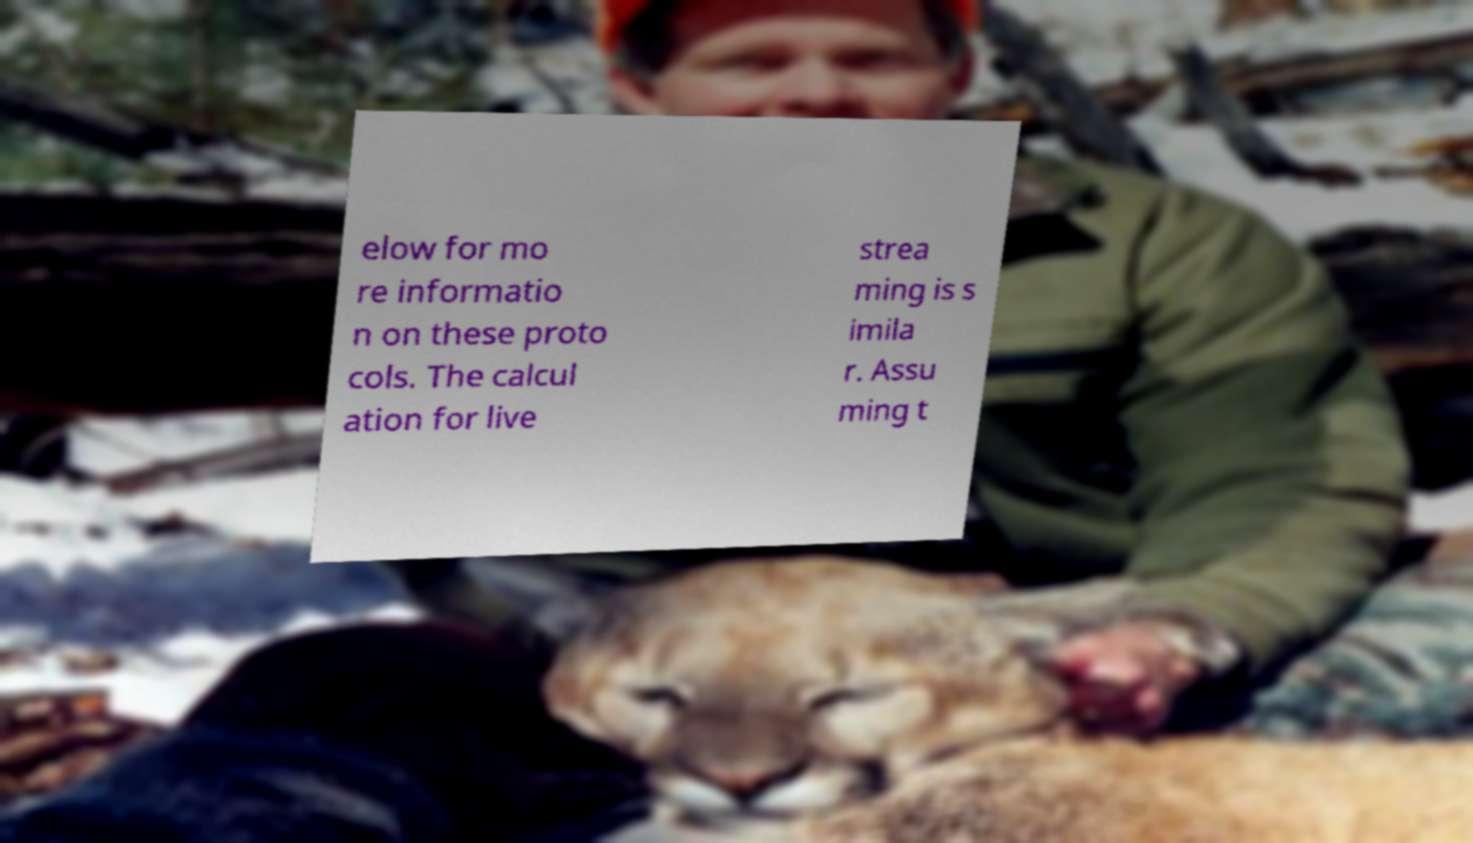Could you extract and type out the text from this image? elow for mo re informatio n on these proto cols. The calcul ation for live strea ming is s imila r. Assu ming t 